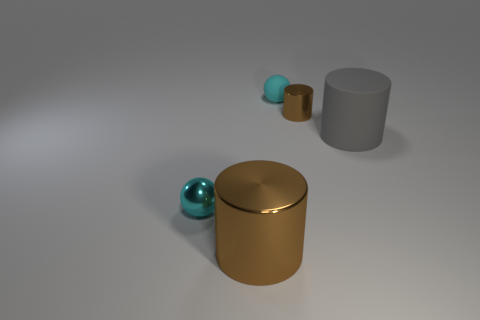Subtract all metal cylinders. How many cylinders are left? 1 Subtract all brown cylinders. How many cylinders are left? 1 Subtract 1 spheres. How many spheres are left? 1 Subtract all brown spheres. How many blue cylinders are left? 0 Subtract 0 brown cubes. How many objects are left? 5 Subtract all cylinders. How many objects are left? 2 Subtract all green spheres. Subtract all red cylinders. How many spheres are left? 2 Subtract all tiny things. Subtract all brown rubber things. How many objects are left? 2 Add 3 large metallic things. How many large metallic things are left? 4 Add 3 balls. How many balls exist? 5 